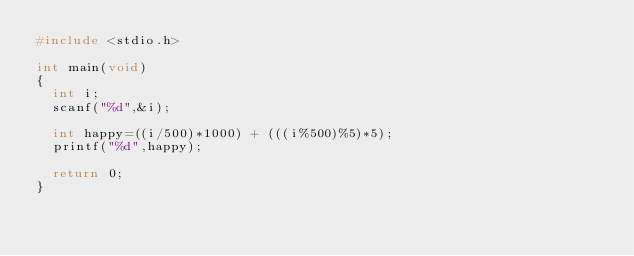<code> <loc_0><loc_0><loc_500><loc_500><_C_>#include <stdio.h>

int main(void)
{
  int i;
  scanf("%d",&i);
  
  int happy=((i/500)*1000) + (((i%500)%5)*5);
  printf("%d",happy);
  
  return 0;
}</code> 